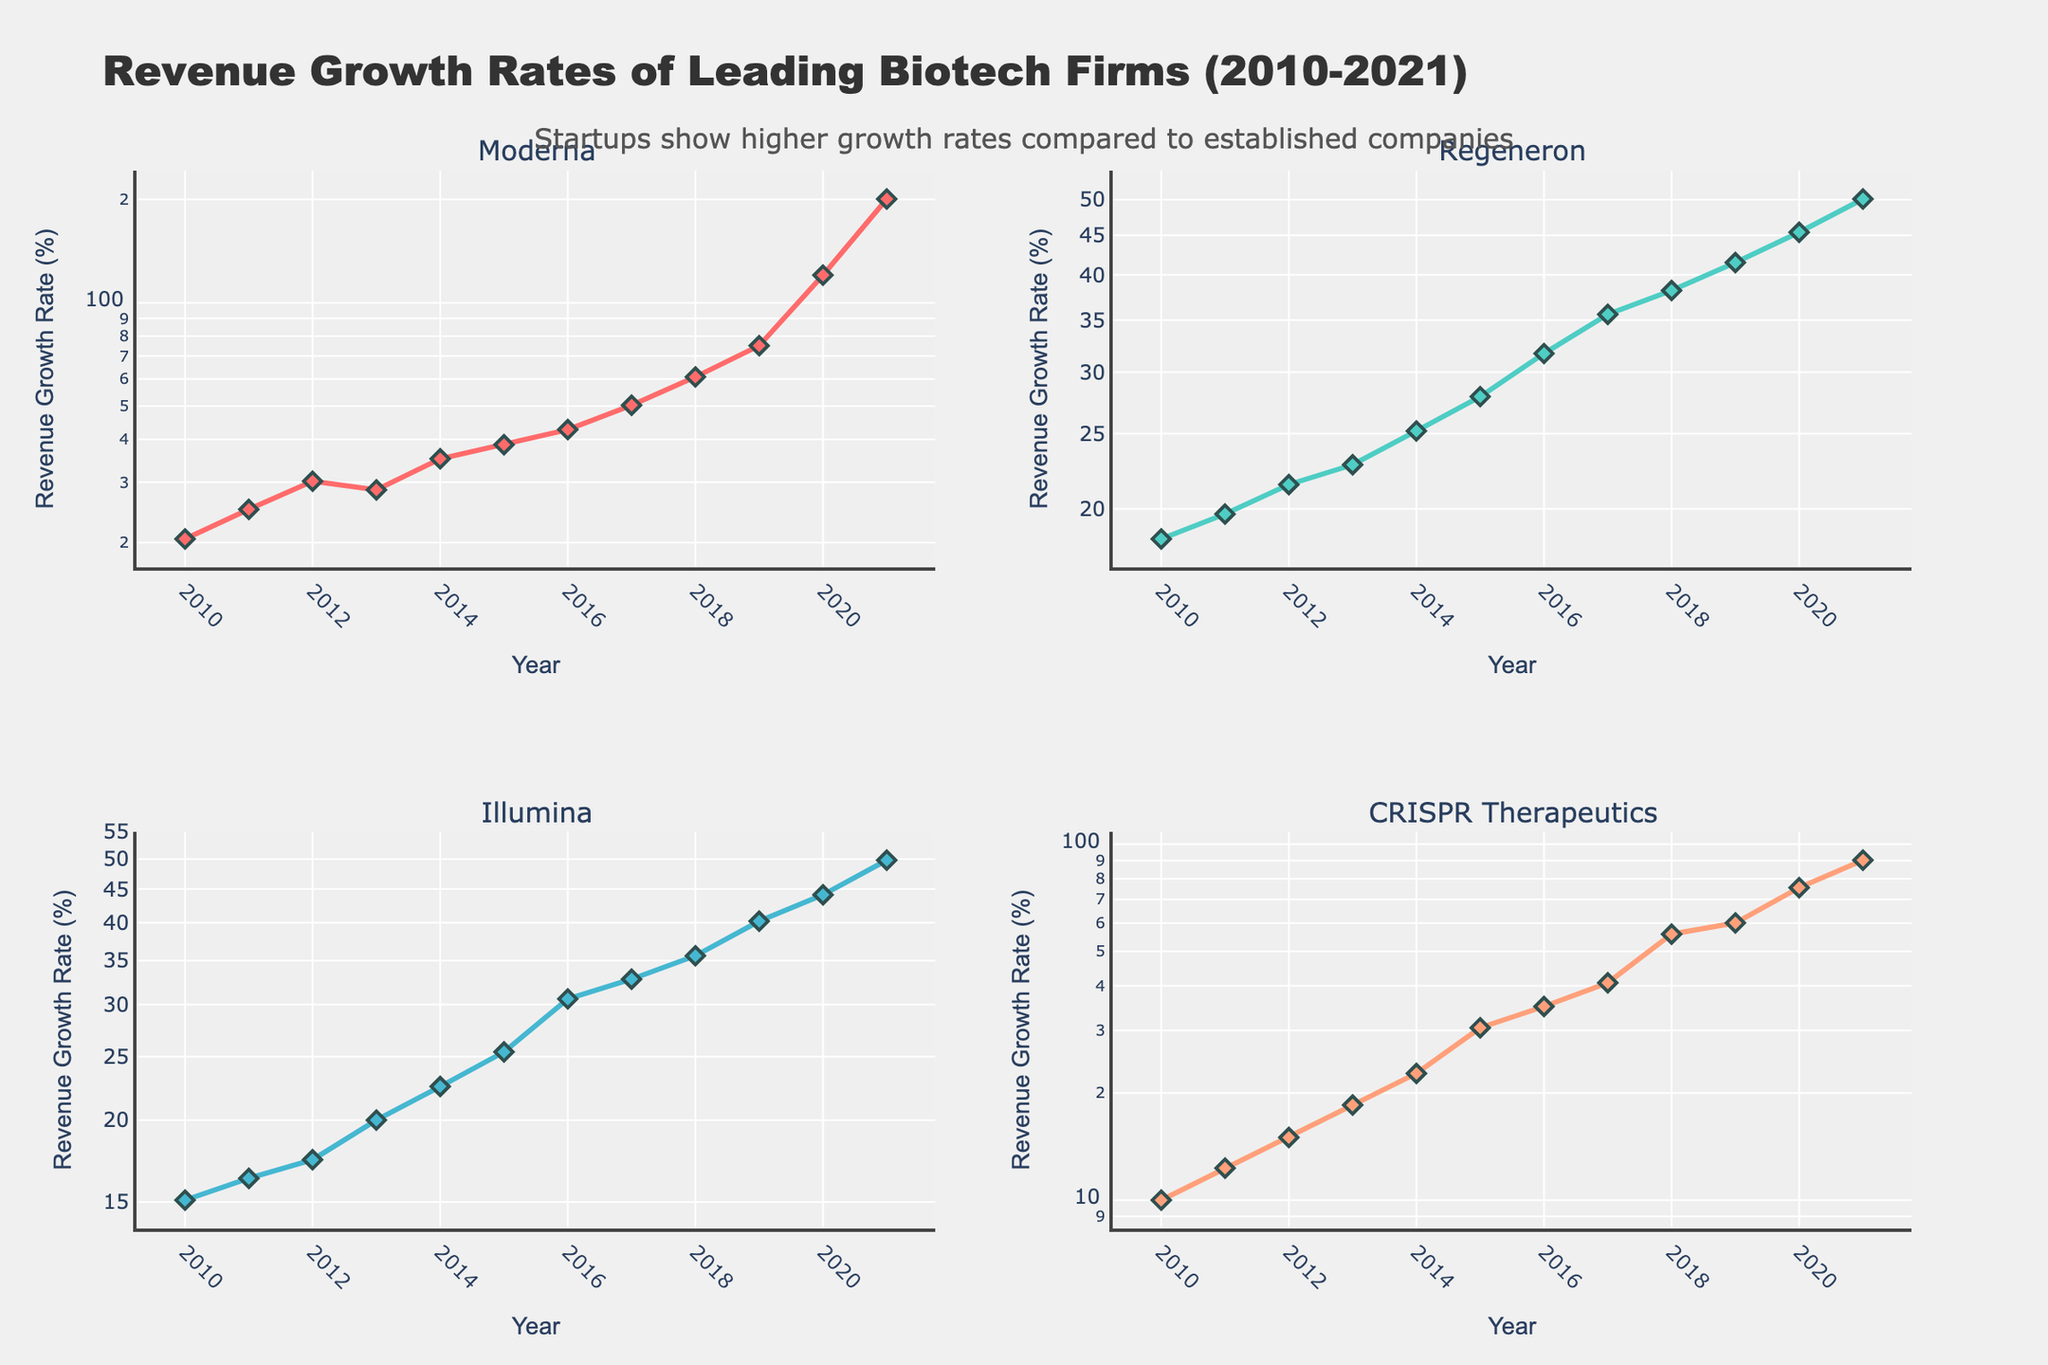What is the title of the figure? The title of the figure is typically located at the top and is clearly stated. In this case, the plot's title Text is "Revenue Growth Rates of Leading Biotech Firms (2010-2021)".
Answer: Revenue Growth Rates of Leading Biotech Firms (2010-2021) How many companies are represented in the figure? The subplot titles indicate the number of companies. According to the provided code that generates the figure, there are four companies: Moderna, Regeneron, Illumina, and CRISPR Therapeutics.
Answer: Four Which company showed the highest revenue growth rate in 2021? Locate the plots for each company and check the data points for 2021. Moderna's plot shows about 200.7% which is the highest among all.
Answer: Moderna How does the growth rate of Illumina in 2019 compare to its growth rate in 2020? Look at Illumina's subplot and compare the points for 2019 and 2020. In 2019, the growth rate is 40.2% and in 2020 it is 44.1%. 44.1% is higher than 40.2%.
Answer: Higher in 2020 What general trend is observed in the revenue growth rates for CRISPR Therapeutics from 2010 to 2021? The increasing slope in CRISPR Therapeutics' subplot indicates a general upward trend over the years from 2010 to 2021.
Answer: Upward trend Which year showed the largest annual revenue growth rate for Moderna? Examine Moderna's subplot and identify the highest point, which is in 2021 with a revenue growth rate of 200.7%.
Answer: 2021 Compare the revenue growth trends of Moderna and Regeneron. Moderna shows a steeper slope and higher growth rates over time while Regeneron's growth is more gradual. This suggests that Moderna has experienced faster and more significant growth compared to Regeneron.
Answer: Moderna grows faster What is the log-scale effect on interpreting growth rates in this subplot? Using a log scale compresses the range of higher values, making exponential growth trends appear linear and easier to visually compare different companies’ growth rates.
Answer: Compresses range and linearizes trends How does the growth rate trend of established companies compare with that of startups in this figure? Established companies like Regeneron and Illumina show more gradual and stable growth rates, while startups like Moderna and CRISPR Therapeutics display steeper and more volatile growth trends.
Answer: Startups are steeper and more volatile 